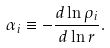Convert formula to latex. <formula><loc_0><loc_0><loc_500><loc_500>\alpha _ { i } \equiv - \frac { d \ln \rho _ { i } } { d \ln r } .</formula> 